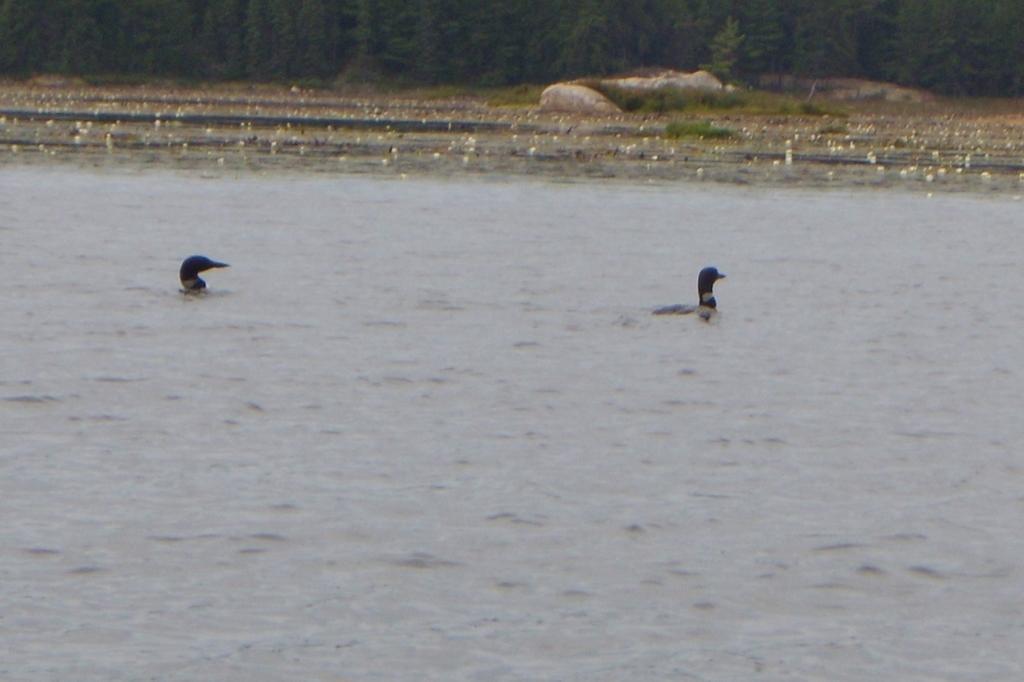In one or two sentences, can you explain what this image depicts? There are ducks in the water in the foreground area, there are trees and stones at the top side. 